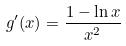Convert formula to latex. <formula><loc_0><loc_0><loc_500><loc_500>g ^ { \prime } ( x ) = \frac { 1 - \ln x } { x ^ { 2 } }</formula> 